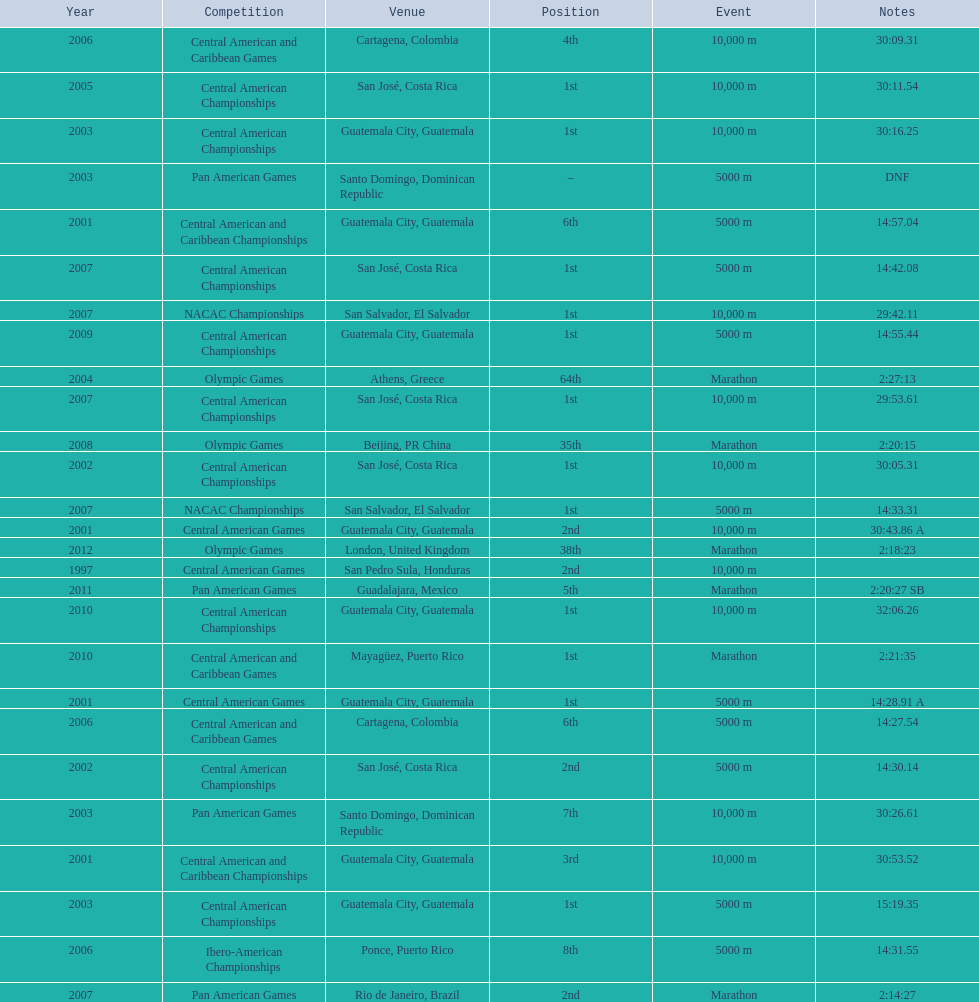The central american championships and what other competition occurred in 2010? Central American and Caribbean Games. 